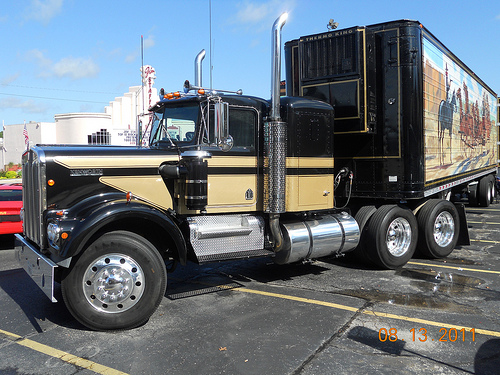<image>
Is there a truck behind the lot? No. The truck is not behind the lot. From this viewpoint, the truck appears to be positioned elsewhere in the scene. Is the vehicle in the road? Yes. The vehicle is contained within or inside the road, showing a containment relationship. Where is the trailer in relation to the truck? Is it above the truck? No. The trailer is not positioned above the truck. The vertical arrangement shows a different relationship. 